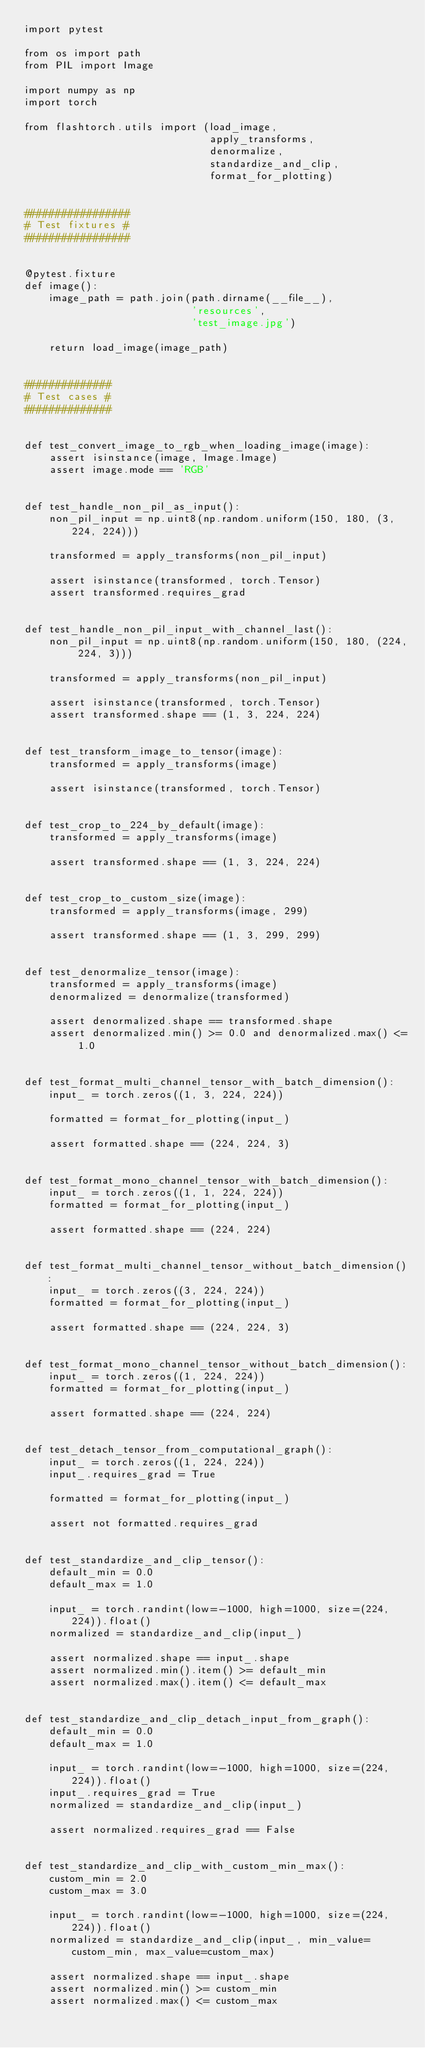<code> <loc_0><loc_0><loc_500><loc_500><_Python_>import pytest

from os import path
from PIL import Image

import numpy as np
import torch

from flashtorch.utils import (load_image,
                              apply_transforms,
                              denormalize,
                              standardize_and_clip,
                              format_for_plotting)


#################
# Test fixtures #
#################


@pytest.fixture
def image():
    image_path = path.join(path.dirname(__file__),
                           'resources',
                           'test_image.jpg')

    return load_image(image_path)


##############
# Test cases #
##############


def test_convert_image_to_rgb_when_loading_image(image):
    assert isinstance(image, Image.Image)
    assert image.mode == 'RGB'


def test_handle_non_pil_as_input():
    non_pil_input = np.uint8(np.random.uniform(150, 180, (3, 224, 224)))

    transformed = apply_transforms(non_pil_input)

    assert isinstance(transformed, torch.Tensor)
    assert transformed.requires_grad


def test_handle_non_pil_input_with_channel_last():
    non_pil_input = np.uint8(np.random.uniform(150, 180, (224, 224, 3)))

    transformed = apply_transforms(non_pil_input)

    assert isinstance(transformed, torch.Tensor)
    assert transformed.shape == (1, 3, 224, 224)


def test_transform_image_to_tensor(image):
    transformed = apply_transforms(image)

    assert isinstance(transformed, torch.Tensor)


def test_crop_to_224_by_default(image):
    transformed = apply_transforms(image)

    assert transformed.shape == (1, 3, 224, 224)


def test_crop_to_custom_size(image):
    transformed = apply_transforms(image, 299)

    assert transformed.shape == (1, 3, 299, 299)


def test_denormalize_tensor(image):
    transformed = apply_transforms(image)
    denormalized = denormalize(transformed)

    assert denormalized.shape == transformed.shape
    assert denormalized.min() >= 0.0 and denormalized.max() <= 1.0


def test_format_multi_channel_tensor_with_batch_dimension():
    input_ = torch.zeros((1, 3, 224, 224))

    formatted = format_for_plotting(input_)

    assert formatted.shape == (224, 224, 3)


def test_format_mono_channel_tensor_with_batch_dimension():
    input_ = torch.zeros((1, 1, 224, 224))
    formatted = format_for_plotting(input_)

    assert formatted.shape == (224, 224)


def test_format_multi_channel_tensor_without_batch_dimension():
    input_ = torch.zeros((3, 224, 224))
    formatted = format_for_plotting(input_)

    assert formatted.shape == (224, 224, 3)


def test_format_mono_channel_tensor_without_batch_dimension():
    input_ = torch.zeros((1, 224, 224))
    formatted = format_for_plotting(input_)

    assert formatted.shape == (224, 224)


def test_detach_tensor_from_computational_graph():
    input_ = torch.zeros((1, 224, 224))
    input_.requires_grad = True

    formatted = format_for_plotting(input_)

    assert not formatted.requires_grad


def test_standardize_and_clip_tensor():
    default_min = 0.0
    default_max = 1.0

    input_ = torch.randint(low=-1000, high=1000, size=(224, 224)).float()
    normalized = standardize_and_clip(input_)

    assert normalized.shape == input_.shape
    assert normalized.min().item() >= default_min
    assert normalized.max().item() <= default_max


def test_standardize_and_clip_detach_input_from_graph():
    default_min = 0.0
    default_max = 1.0

    input_ = torch.randint(low=-1000, high=1000, size=(224, 224)).float()
    input_.requires_grad = True
    normalized = standardize_and_clip(input_)

    assert normalized.requires_grad == False


def test_standardize_and_clip_with_custom_min_max():
    custom_min = 2.0
    custom_max = 3.0

    input_ = torch.randint(low=-1000, high=1000, size=(224, 224)).float()
    normalized = standardize_and_clip(input_, min_value=custom_min, max_value=custom_max)

    assert normalized.shape == input_.shape
    assert normalized.min() >= custom_min
    assert normalized.max() <= custom_max

</code> 